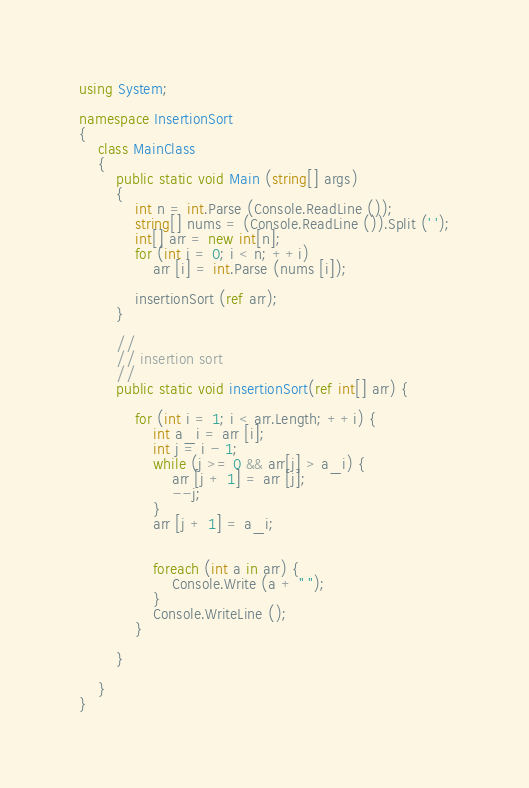Convert code to text. <code><loc_0><loc_0><loc_500><loc_500><_C#_>using System;

namespace InsertionSort
{
	class MainClass
	{
		public static void Main (string[] args)
		{
			int n = int.Parse (Console.ReadLine ());
			string[] nums = (Console.ReadLine ()).Split (' ');
			int[] arr = new int[n];
			for (int i = 0; i < n; ++i)
				arr [i] = int.Parse (nums [i]);

			insertionSort (ref arr);
		}

		//
		// insertion sort
		//
		public static void insertionSort(ref int[] arr) {

			for (int i = 1; i < arr.Length; ++i) {
				int a_i = arr [i];
				int j = i - 1;
				while (j >= 0 && arr[j] > a_i) {
					arr [j + 1] = arr [j];
					--j;
				}
				arr [j + 1] = a_i;


				foreach (int a in arr) {
					Console.Write (a + " ");
				}
				Console.WriteLine ();
			}

		}

	}
}</code> 